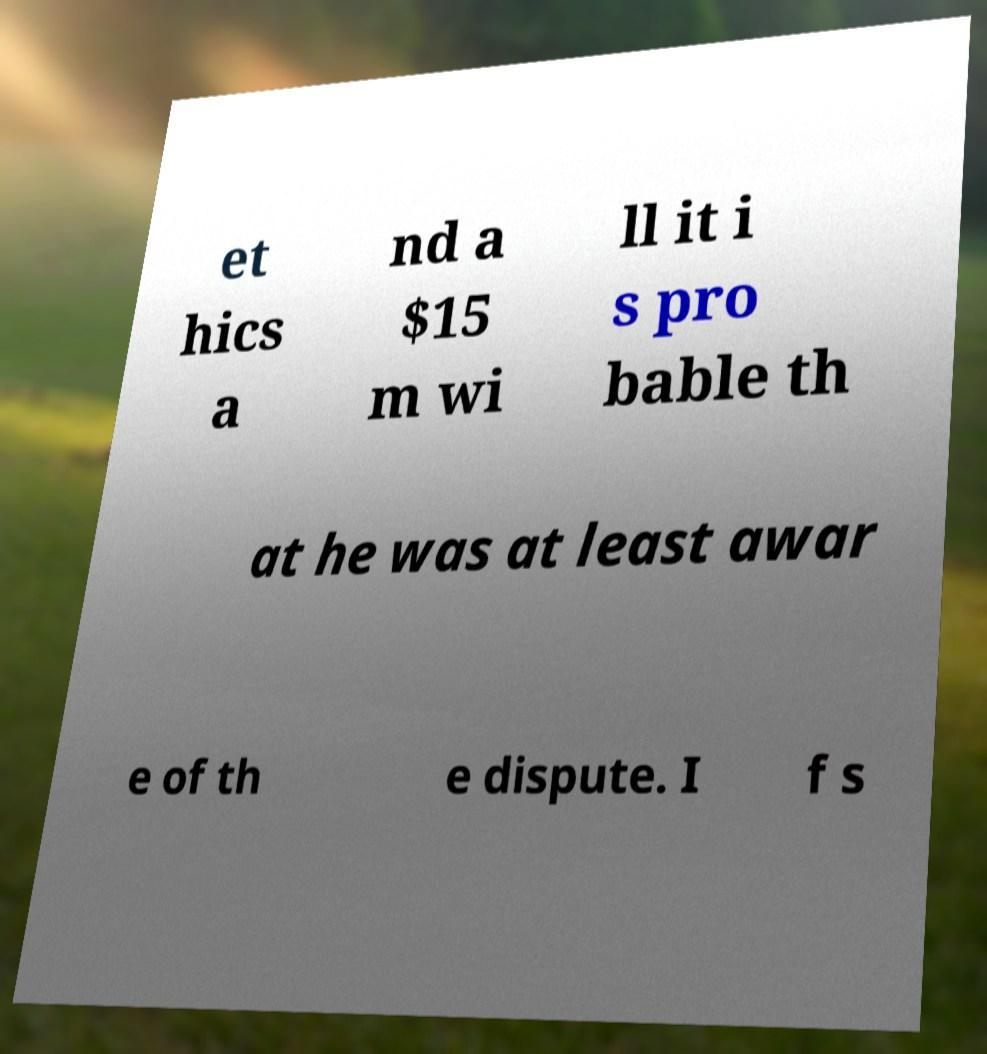Please read and relay the text visible in this image. What does it say? et hics a nd a $15 m wi ll it i s pro bable th at he was at least awar e of th e dispute. I f s 